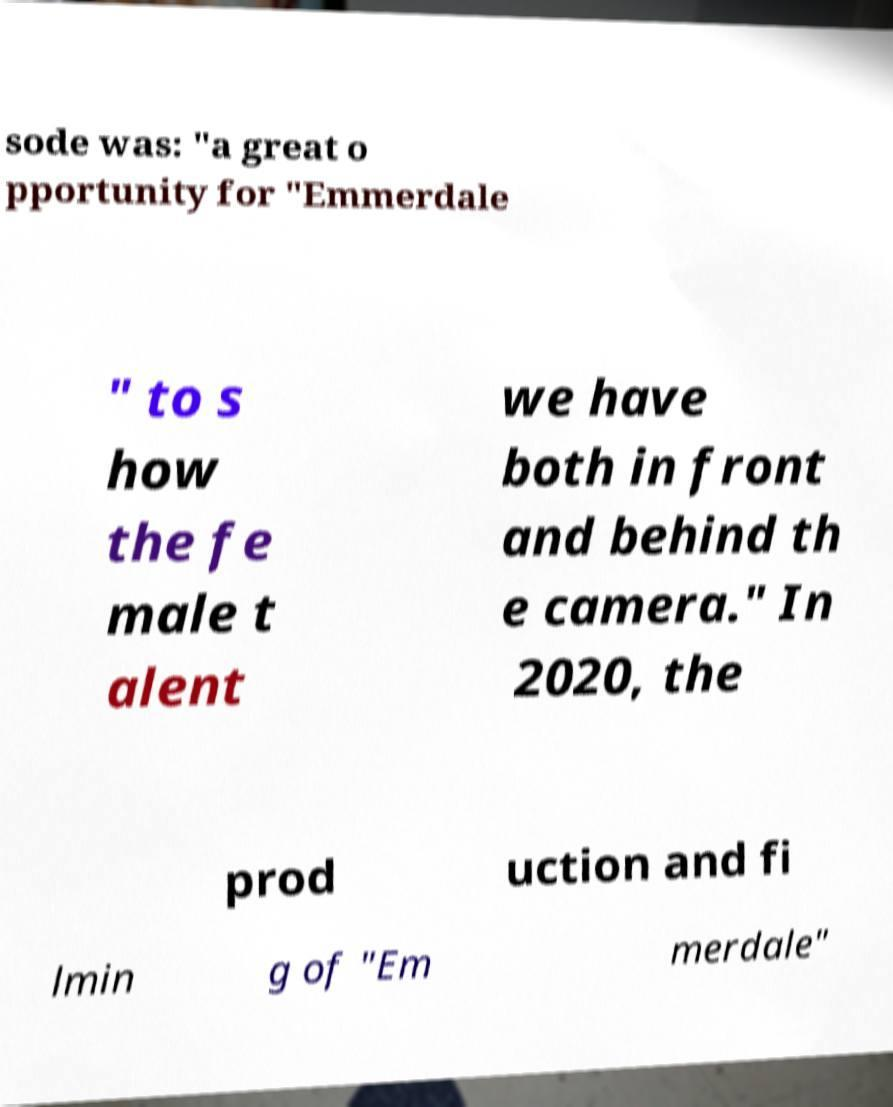There's text embedded in this image that I need extracted. Can you transcribe it verbatim? sode was: "a great o pportunity for "Emmerdale " to s how the fe male t alent we have both in front and behind th e camera." In 2020, the prod uction and fi lmin g of "Em merdale" 